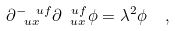<formula> <loc_0><loc_0><loc_500><loc_500>\partial _ { \ u x } ^ { - \ u f } \partial _ { \ u x } ^ { \ u f } \phi = \lambda ^ { 2 } \phi \ \ ,</formula> 